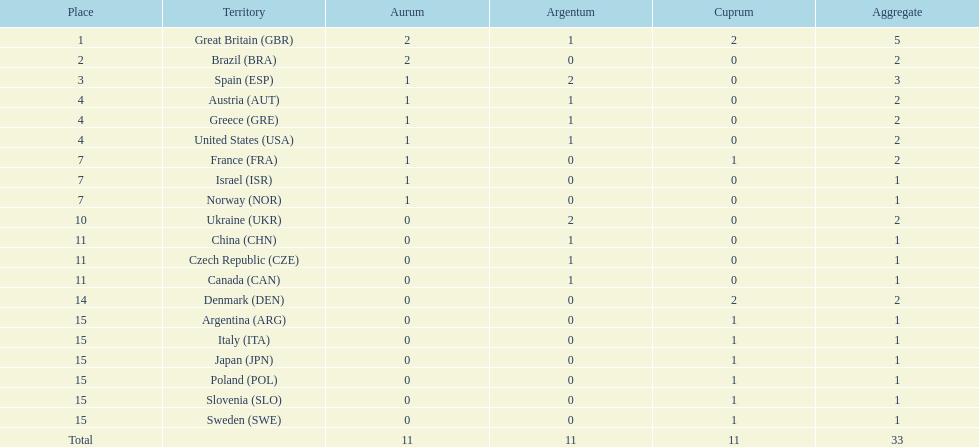Parse the table in full. {'header': ['Place', 'Territory', 'Aurum', 'Argentum', 'Cuprum', 'Aggregate'], 'rows': [['1', 'Great Britain\xa0(GBR)', '2', '1', '2', '5'], ['2', 'Brazil\xa0(BRA)', '2', '0', '0', '2'], ['3', 'Spain\xa0(ESP)', '1', '2', '0', '3'], ['4', 'Austria\xa0(AUT)', '1', '1', '0', '2'], ['4', 'Greece\xa0(GRE)', '1', '1', '0', '2'], ['4', 'United States\xa0(USA)', '1', '1', '0', '2'], ['7', 'France\xa0(FRA)', '1', '0', '1', '2'], ['7', 'Israel\xa0(ISR)', '1', '0', '0', '1'], ['7', 'Norway\xa0(NOR)', '1', '0', '0', '1'], ['10', 'Ukraine\xa0(UKR)', '0', '2', '0', '2'], ['11', 'China\xa0(CHN)', '0', '1', '0', '1'], ['11', 'Czech Republic\xa0(CZE)', '0', '1', '0', '1'], ['11', 'Canada\xa0(CAN)', '0', '1', '0', '1'], ['14', 'Denmark\xa0(DEN)', '0', '0', '2', '2'], ['15', 'Argentina\xa0(ARG)', '0', '0', '1', '1'], ['15', 'Italy\xa0(ITA)', '0', '0', '1', '1'], ['15', 'Japan\xa0(JPN)', '0', '0', '1', '1'], ['15', 'Poland\xa0(POL)', '0', '0', '1', '1'], ['15', 'Slovenia\xa0(SLO)', '0', '0', '1', '1'], ['15', 'Sweden\xa0(SWE)', '0', '0', '1', '1'], ['Total', '', '11', '11', '11', '33']]} How many countries won at least 2 medals in sailing? 9. 